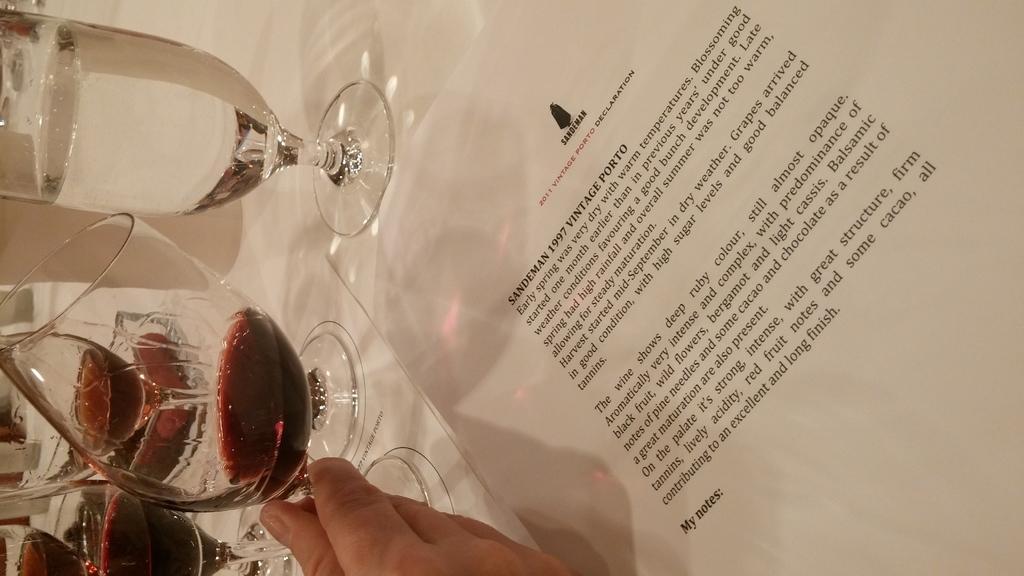Can you describe this image briefly? In this image we can see glasses with liquid and a paper on a table. At the bottom of the image we can see hand of a person which is truncated. 